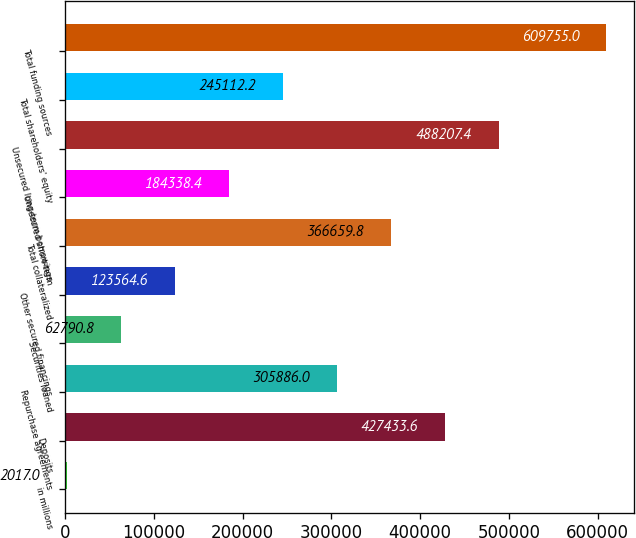Convert chart. <chart><loc_0><loc_0><loc_500><loc_500><bar_chart><fcel>in millions<fcel>Deposits<fcel>Repurchase agreements<fcel>Securities loaned<fcel>Other secured financings<fcel>Total collateralized<fcel>Unsecured short-term<fcel>Unsecured long-term borrowings<fcel>Total shareholders' equity<fcel>Total funding sources<nl><fcel>2017<fcel>427434<fcel>305886<fcel>62790.8<fcel>123565<fcel>366660<fcel>184338<fcel>488207<fcel>245112<fcel>609755<nl></chart> 